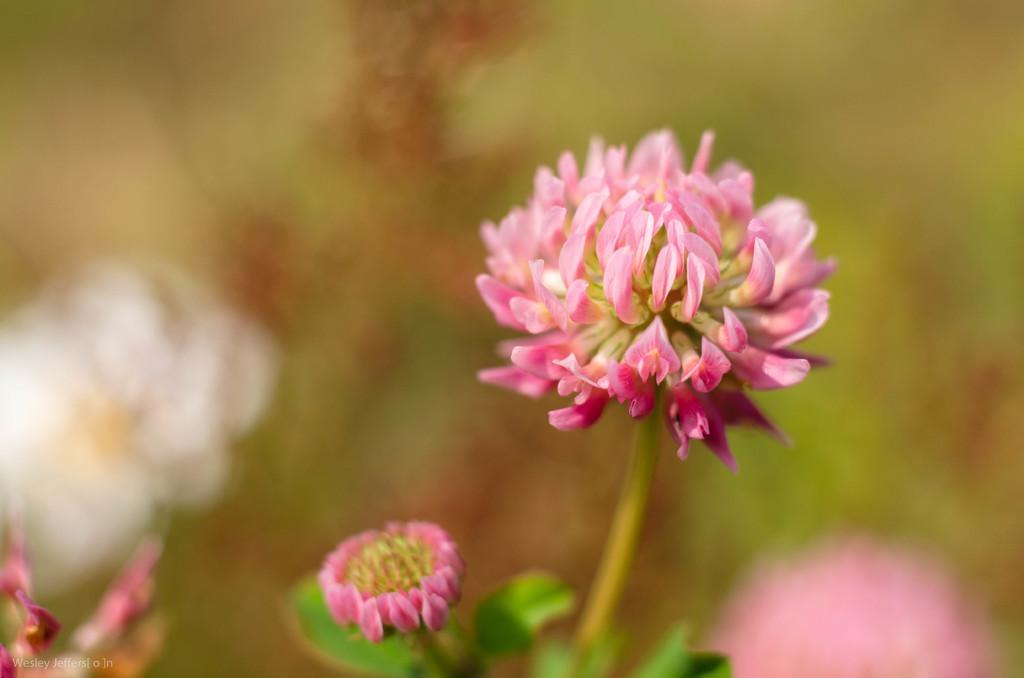Please provide a concise description of this image. This is a macro photography of a flower. I can see some text in the bottom left corner. 